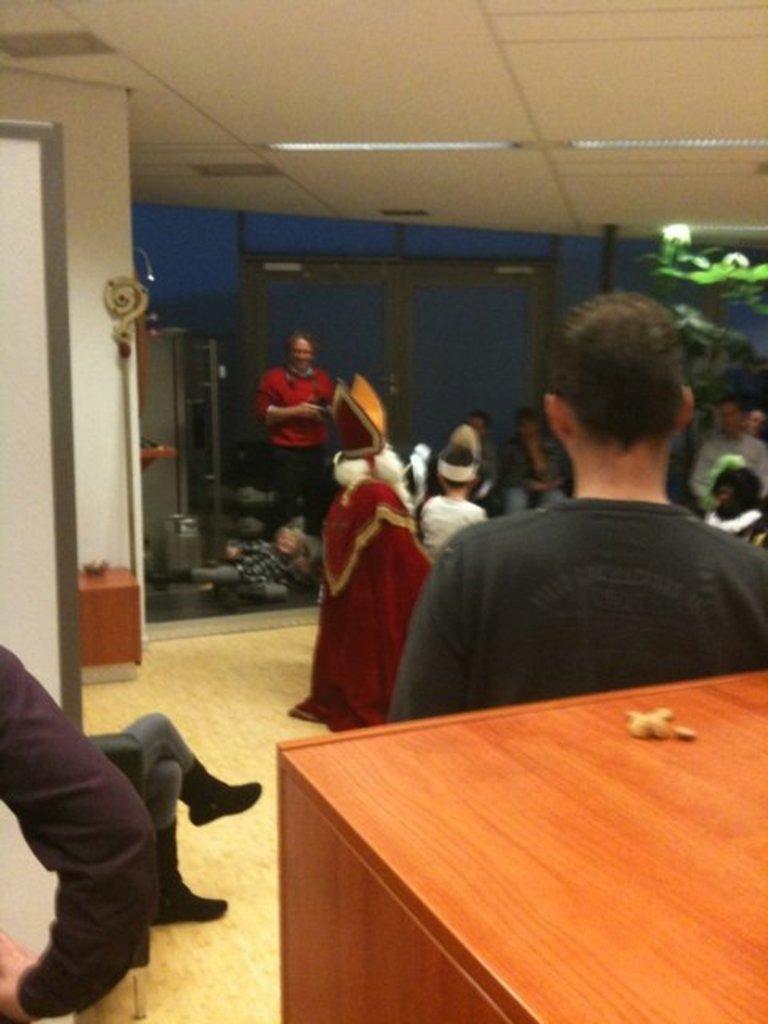Could you give a brief overview of what you see in this image? This is looking like a room. One person is standing here and wearing a red t shirt. One small boy is lying on the floor. There is a shelf in this room. In the background it looks like blue color and there is a table in this room. 